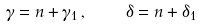Convert formula to latex. <formula><loc_0><loc_0><loc_500><loc_500>\gamma = n + \gamma _ { 1 } \, , \quad \delta = n + \delta _ { 1 }</formula> 